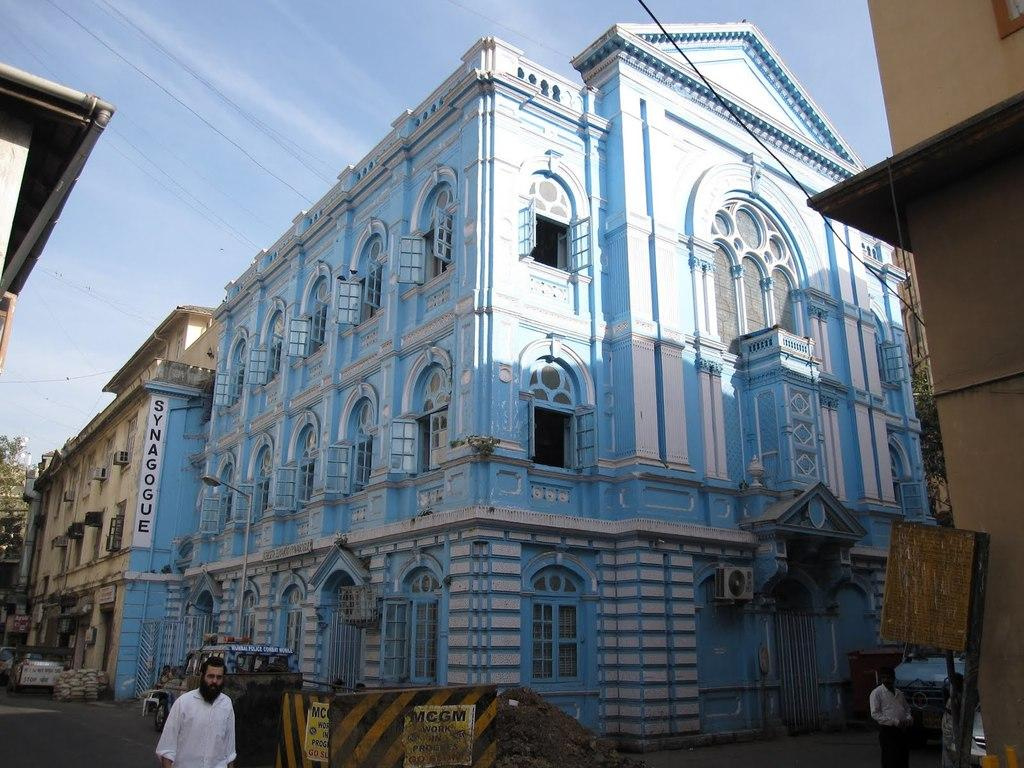What is the main structure in the image? There is a building in the image. What colors are used for the building? The building is blue and white in color. Who is present on the left side of the image? There is a man on the left side of the image. What is the man wearing? The man is wearing a white dress. What can be seen at the top of the image? The sky is visible at the top of the image. What is the weather like in the image? The sky is sunny, indicating a clear and bright day. Where is the garden located in the image? There is no garden present in the image. What type of precipitation is falling from the sky in the image? There is no precipitation visible in the image; the sky is sunny. 